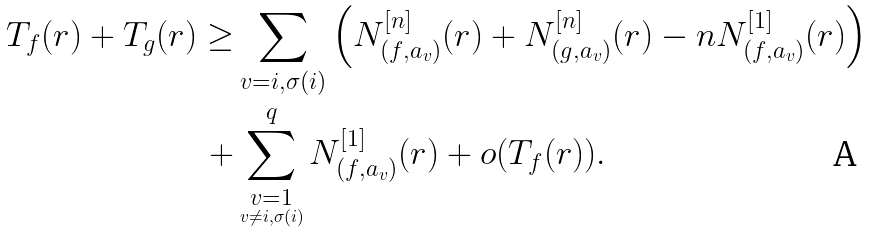Convert formula to latex. <formula><loc_0><loc_0><loc_500><loc_500>T _ { f } ( r ) + T _ { g } ( r ) \geq & \sum _ { v = i , \sigma ( i ) } \left ( N ^ { [ n ] } _ { ( f , a _ { v } ) } ( r ) + N ^ { [ n ] } _ { ( g , a _ { v } ) } ( r ) - n N ^ { [ 1 ] } _ { ( f , a _ { v } ) } ( r ) \right ) \\ + & \sum _ { \underset { v \ne i , \sigma ( i ) } { v = 1 } } ^ { q } N ^ { [ 1 ] } _ { ( f , a _ { v } ) } ( r ) + o ( T _ { f } ( r ) ) .</formula> 